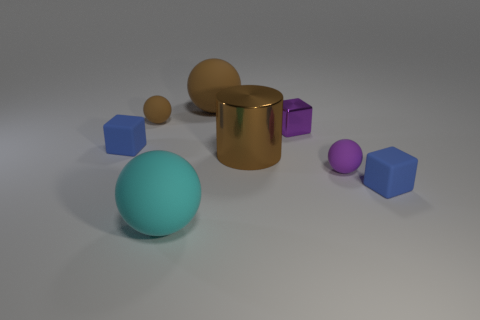What number of other things are the same size as the purple cube?
Ensure brevity in your answer.  4. There is a large rubber ball in front of the big rubber thing on the right side of the big cyan matte object; is there a large matte ball left of it?
Keep it short and to the point. No. What size is the brown metal cylinder?
Provide a succinct answer. Large. How big is the blue matte cube right of the cyan thing?
Keep it short and to the point. Small. Is the size of the matte block in front of the purple matte object the same as the small purple matte thing?
Your answer should be very brief. Yes. Is there anything else that has the same color as the cylinder?
Your response must be concise. Yes. The large brown rubber object is what shape?
Your answer should be very brief. Sphere. How many matte things are both in front of the large brown shiny cylinder and to the left of the purple matte thing?
Ensure brevity in your answer.  1. Do the small metal object and the cylinder have the same color?
Ensure brevity in your answer.  No. What is the material of the large cyan object that is the same shape as the tiny brown rubber thing?
Keep it short and to the point. Rubber. 